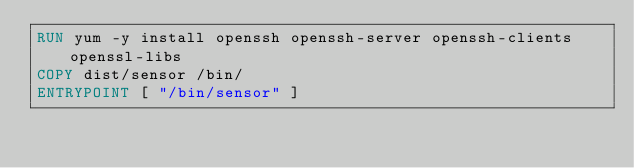<code> <loc_0><loc_0><loc_500><loc_500><_Dockerfile_>RUN yum -y install openssh openssh-server openssh-clients openssl-libs
COPY dist/sensor /bin/
ENTRYPOINT [ "/bin/sensor" ]</code> 